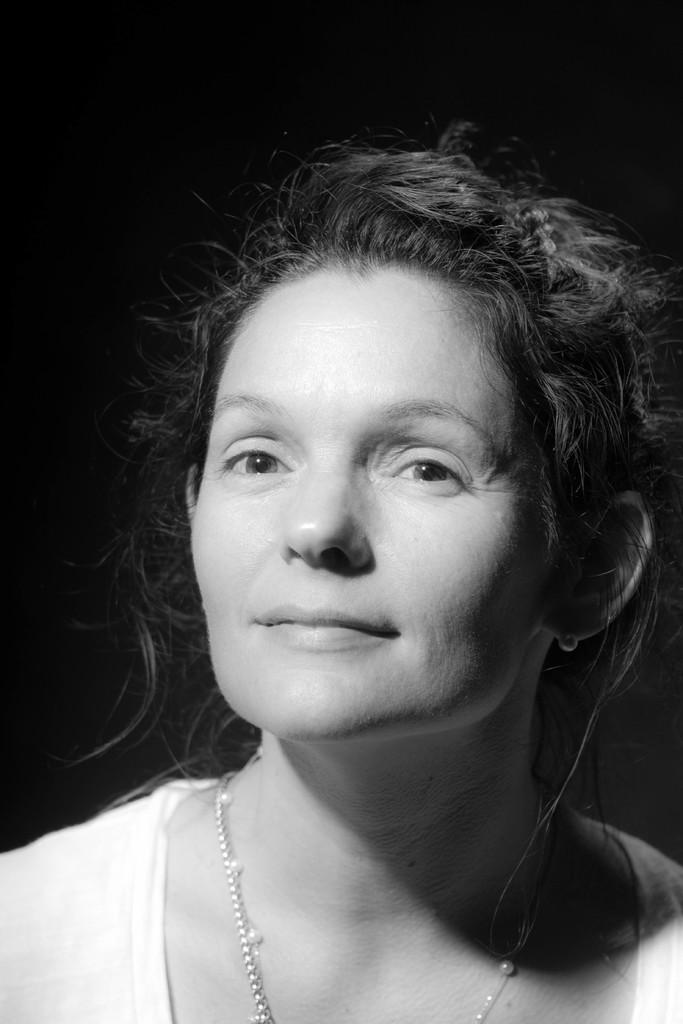What is the main subject of the image? There is a person in the image. Can you describe the background of the image? The background of the image is dark. What type of cap can be seen floating in the water at the seashore in the image? There is no seashore or cap present in the image; it features a person with a dark background. 